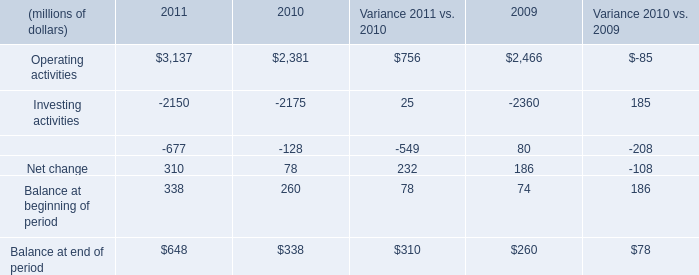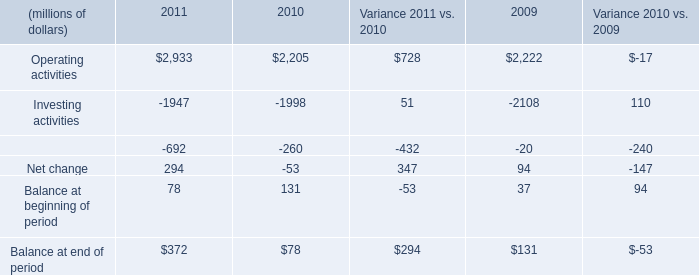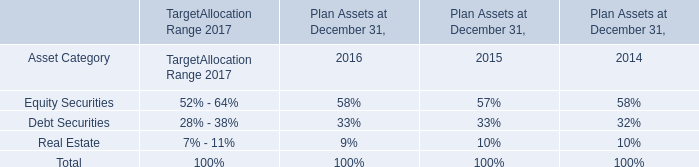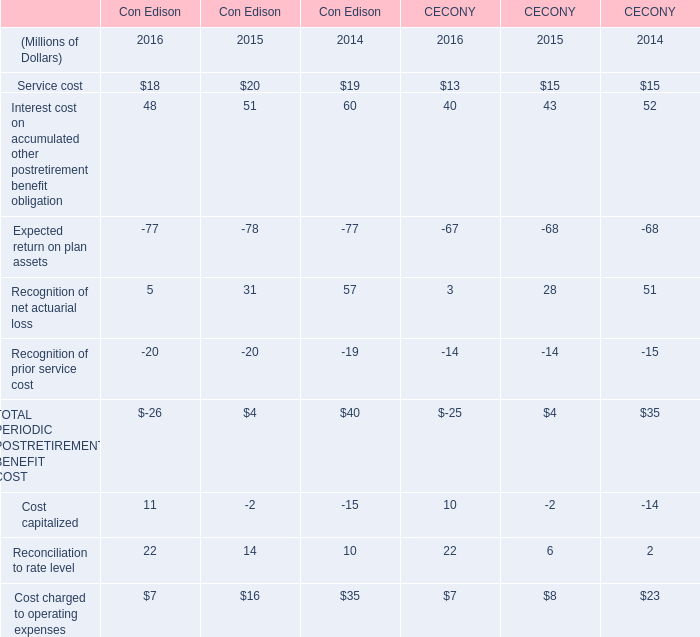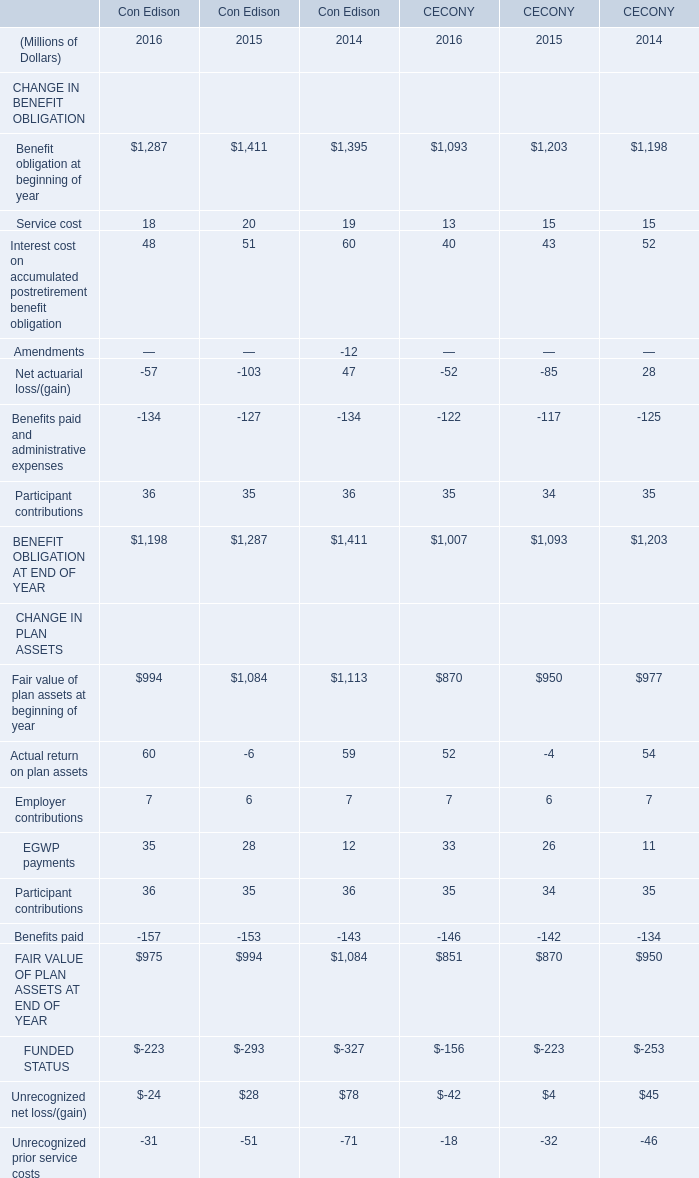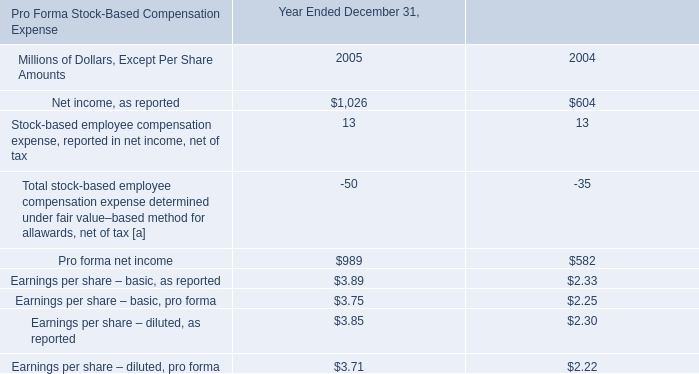In the year with largest amount of Reconciliation to rate level of Con Edison, what's the increasing rate of Cost charged to operating expenses of Con Edison? 
Computations: ((7 - 16) / 16)
Answer: -0.5625. 